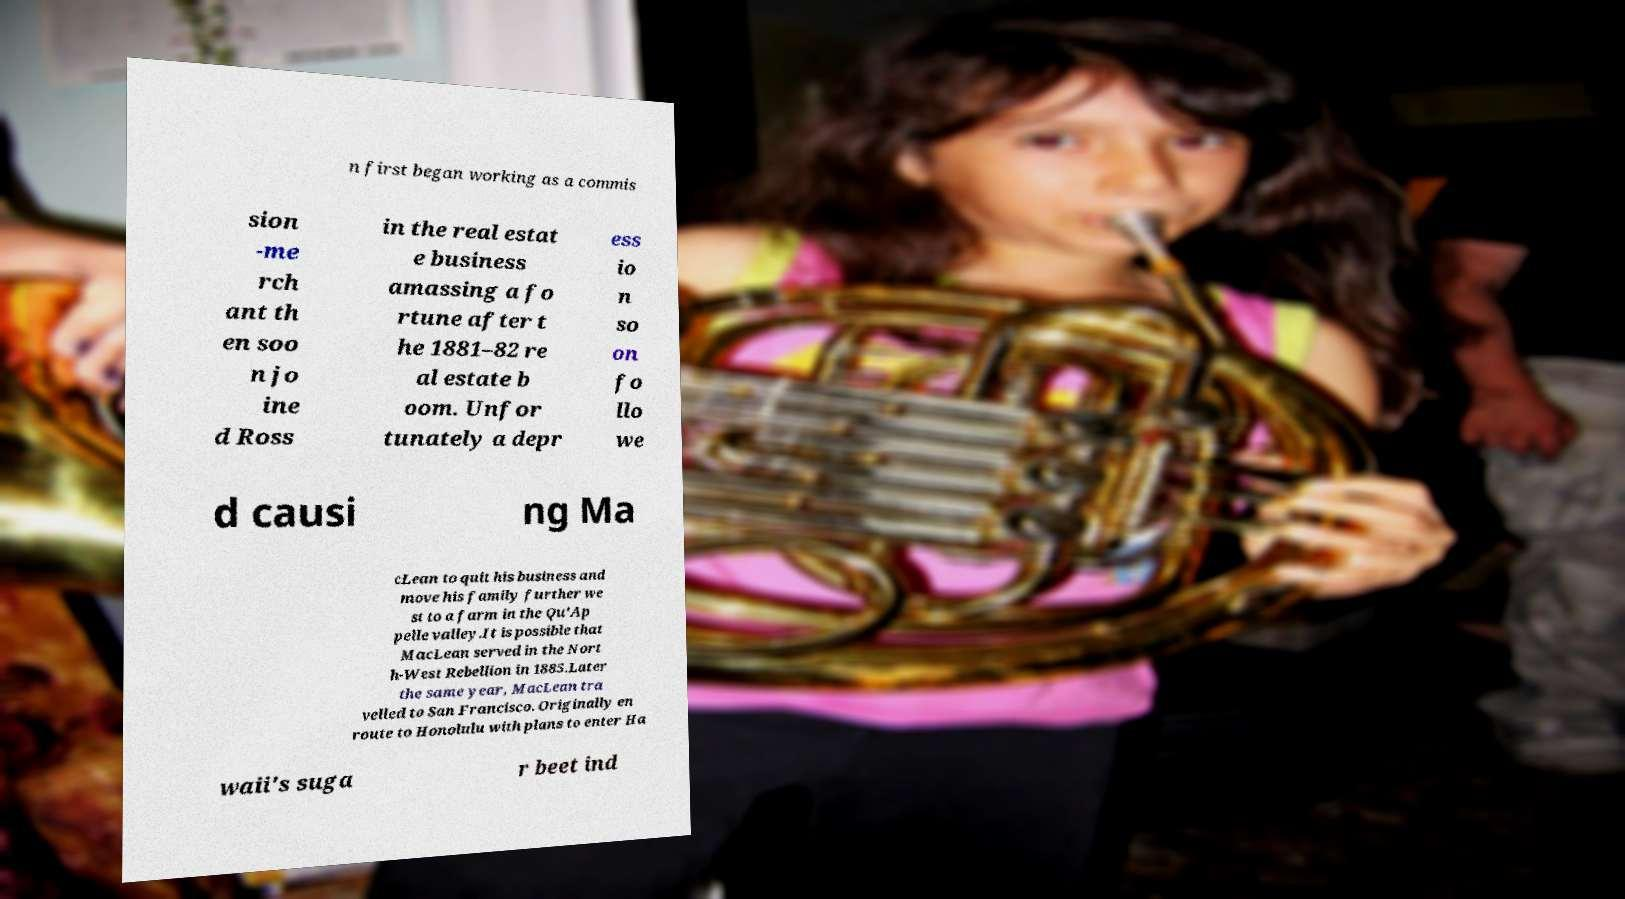Can you accurately transcribe the text from the provided image for me? n first began working as a commis sion -me rch ant th en soo n jo ine d Ross in the real estat e business amassing a fo rtune after t he 1881–82 re al estate b oom. Unfor tunately a depr ess io n so on fo llo we d causi ng Ma cLean to quit his business and move his family further we st to a farm in the Qu'Ap pelle valley.It is possible that MacLean served in the Nort h-West Rebellion in 1885.Later the same year, MacLean tra velled to San Francisco. Originally en route to Honolulu with plans to enter Ha waii's suga r beet ind 